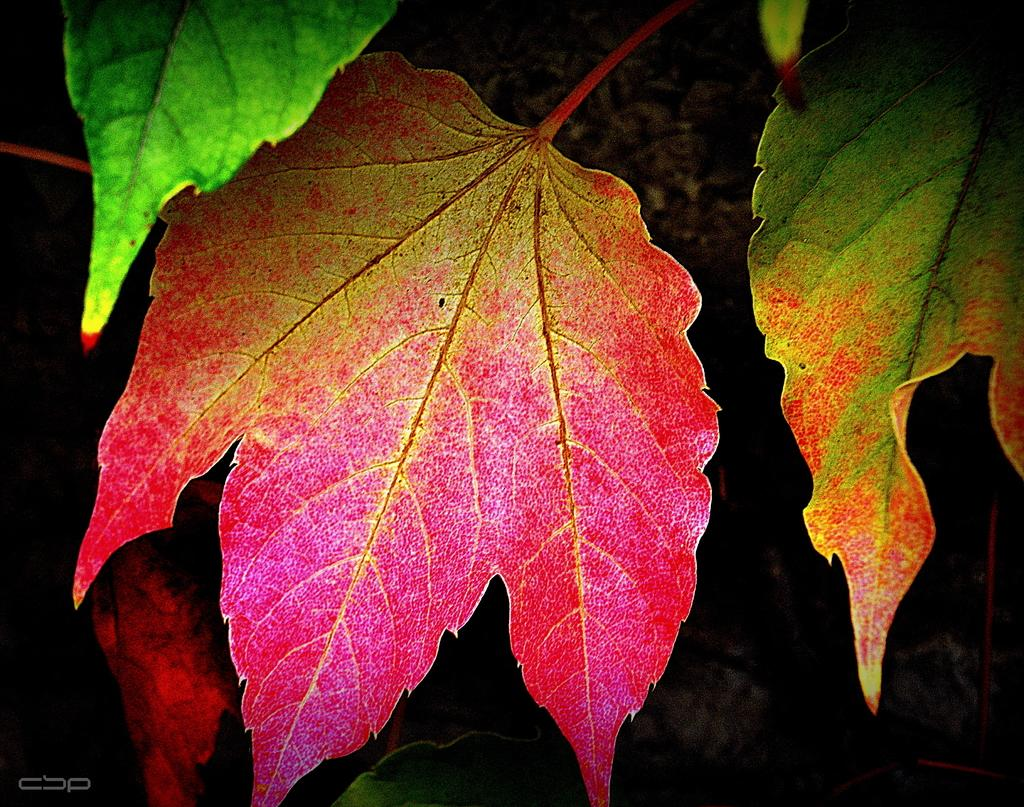What type of vegetation can be seen in the image? There are leaves in the image. What type of drug is the bear using in the image? There is no bear or drug present in the image; it only features leaves. 